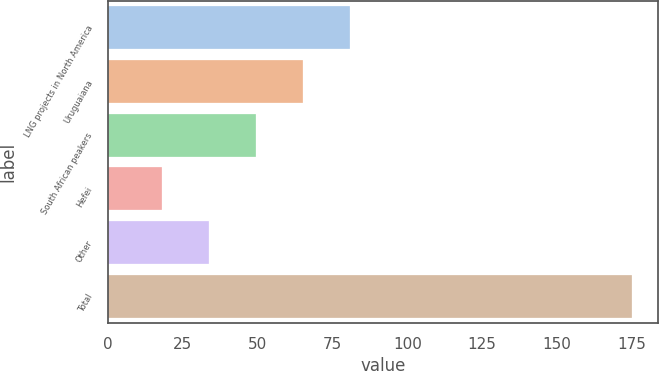<chart> <loc_0><loc_0><loc_500><loc_500><bar_chart><fcel>LNG projects in North America<fcel>Uruguaiana<fcel>South African peakers<fcel>Hefei<fcel>Other<fcel>Total<nl><fcel>80.8<fcel>65.1<fcel>49.4<fcel>18<fcel>33.7<fcel>175<nl></chart> 